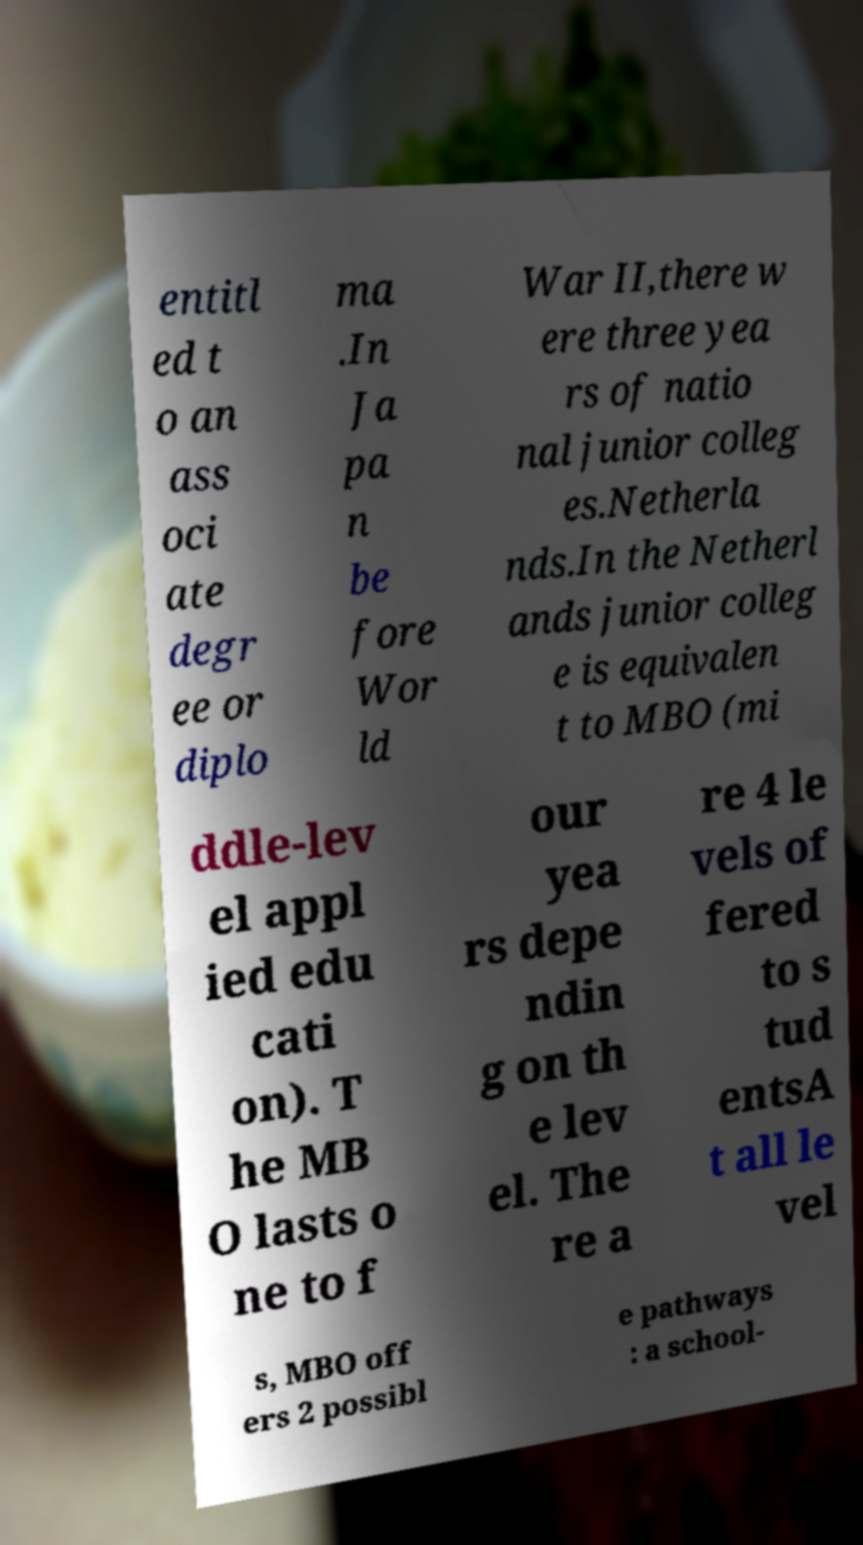Could you assist in decoding the text presented in this image and type it out clearly? entitl ed t o an ass oci ate degr ee or diplo ma .In Ja pa n be fore Wor ld War II,there w ere three yea rs of natio nal junior colleg es.Netherla nds.In the Netherl ands junior colleg e is equivalen t to MBO (mi ddle-lev el appl ied edu cati on). T he MB O lasts o ne to f our yea rs depe ndin g on th e lev el. The re a re 4 le vels of fered to s tud entsA t all le vel s, MBO off ers 2 possibl e pathways : a school- 